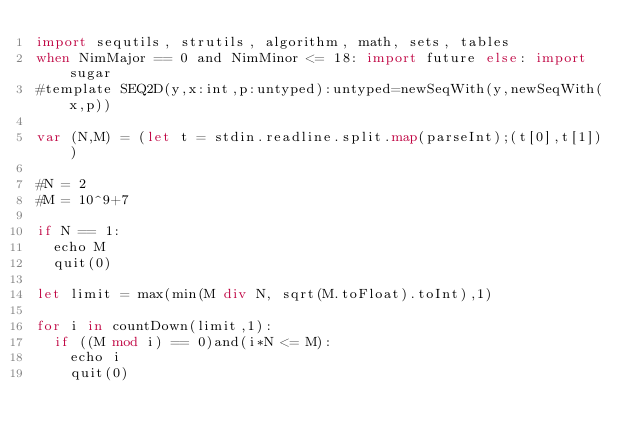<code> <loc_0><loc_0><loc_500><loc_500><_Nim_>import sequtils, strutils, algorithm, math, sets, tables
when NimMajor == 0 and NimMinor <= 18: import future else: import sugar
#template SEQ2D(y,x:int,p:untyped):untyped=newSeqWith(y,newSeqWith(x,p))

var (N,M) = (let t = stdin.readline.split.map(parseInt);(t[0],t[1]))

#N = 2
#M = 10^9+7

if N == 1:
  echo M
  quit(0)

let limit = max(min(M div N, sqrt(M.toFloat).toInt),1)

for i in countDown(limit,1):
  if ((M mod i) == 0)and(i*N <= M):
    echo i
    quit(0)
</code> 